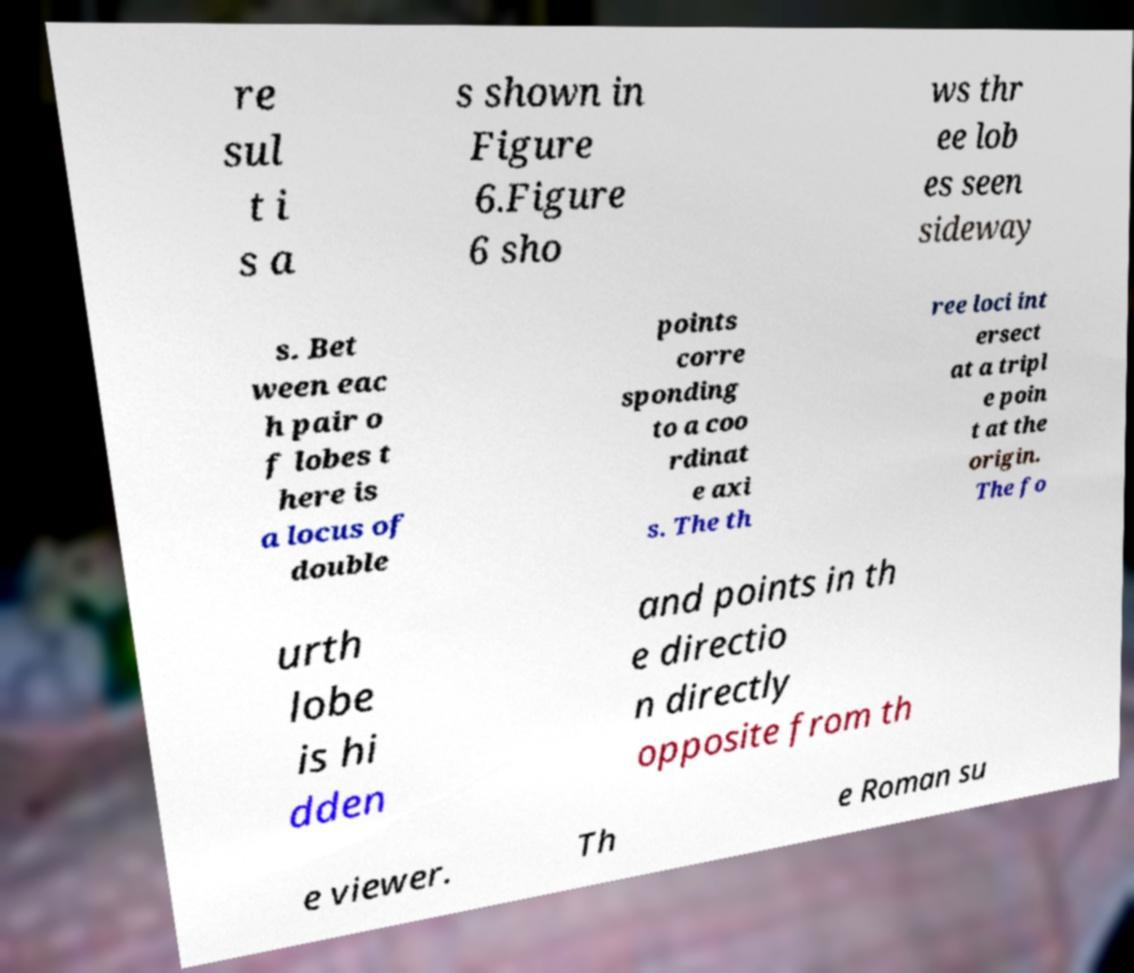Please read and relay the text visible in this image. What does it say? re sul t i s a s shown in Figure 6.Figure 6 sho ws thr ee lob es seen sideway s. Bet ween eac h pair o f lobes t here is a locus of double points corre sponding to a coo rdinat e axi s. The th ree loci int ersect at a tripl e poin t at the origin. The fo urth lobe is hi dden and points in th e directio n directly opposite from th e viewer. Th e Roman su 